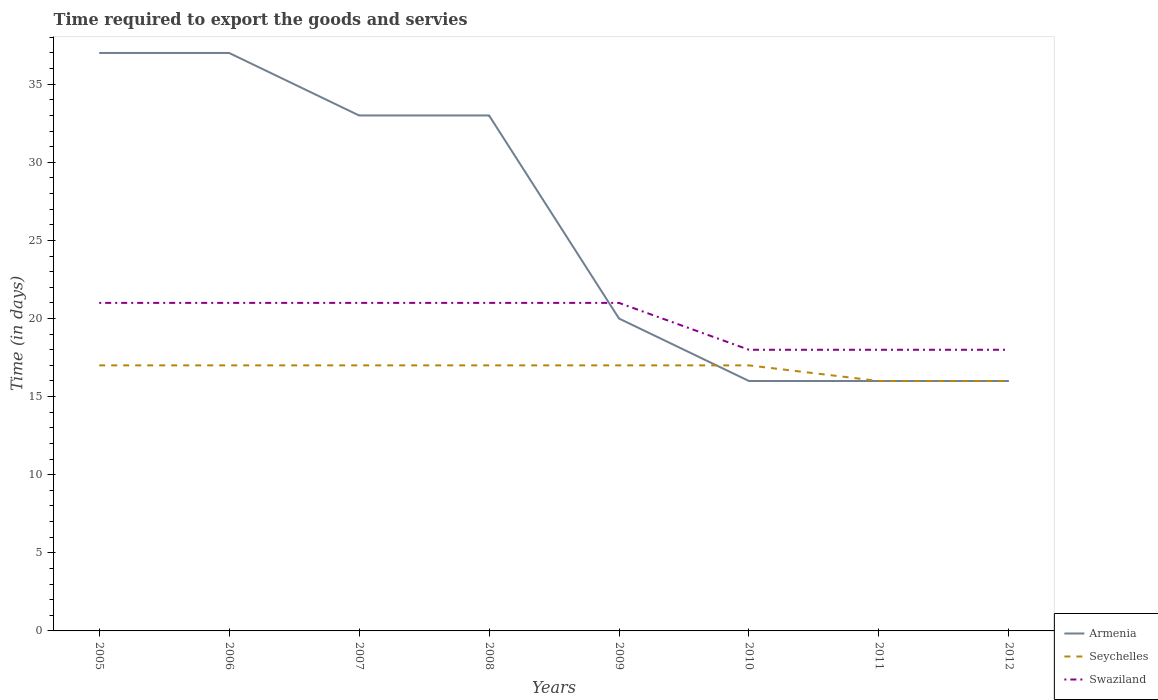Across all years, what is the maximum number of days required to export the goods and services in Swaziland?
Make the answer very short. 18. What is the total number of days required to export the goods and services in Armenia in the graph?
Your answer should be very brief. 13. What is the difference between the highest and the second highest number of days required to export the goods and services in Swaziland?
Your answer should be very brief. 3. What is the difference between the highest and the lowest number of days required to export the goods and services in Armenia?
Ensure brevity in your answer.  4. Is the number of days required to export the goods and services in Seychelles strictly greater than the number of days required to export the goods and services in Swaziland over the years?
Give a very brief answer. Yes. What is the difference between two consecutive major ticks on the Y-axis?
Offer a terse response. 5. Are the values on the major ticks of Y-axis written in scientific E-notation?
Keep it short and to the point. No. Does the graph contain any zero values?
Make the answer very short. No. How many legend labels are there?
Provide a short and direct response. 3. What is the title of the graph?
Ensure brevity in your answer.  Time required to export the goods and servies. Does "Austria" appear as one of the legend labels in the graph?
Ensure brevity in your answer.  No. What is the label or title of the Y-axis?
Your answer should be very brief. Time (in days). What is the Time (in days) in Armenia in 2005?
Ensure brevity in your answer.  37. What is the Time (in days) of Seychelles in 2006?
Keep it short and to the point. 17. What is the Time (in days) in Seychelles in 2007?
Give a very brief answer. 17. What is the Time (in days) in Swaziland in 2007?
Offer a terse response. 21. What is the Time (in days) in Armenia in 2008?
Your answer should be compact. 33. What is the Time (in days) in Seychelles in 2008?
Keep it short and to the point. 17. What is the Time (in days) in Swaziland in 2008?
Make the answer very short. 21. What is the Time (in days) of Seychelles in 2010?
Ensure brevity in your answer.  17. What is the Time (in days) in Swaziland in 2010?
Provide a succinct answer. 18. What is the Time (in days) of Armenia in 2011?
Provide a short and direct response. 16. What is the Time (in days) in Armenia in 2012?
Your response must be concise. 16. What is the Time (in days) of Seychelles in 2012?
Keep it short and to the point. 16. What is the Time (in days) of Swaziland in 2012?
Keep it short and to the point. 18. Across all years, what is the maximum Time (in days) in Swaziland?
Your answer should be compact. 21. Across all years, what is the minimum Time (in days) in Seychelles?
Keep it short and to the point. 16. Across all years, what is the minimum Time (in days) of Swaziland?
Ensure brevity in your answer.  18. What is the total Time (in days) in Armenia in the graph?
Your response must be concise. 208. What is the total Time (in days) in Seychelles in the graph?
Keep it short and to the point. 134. What is the total Time (in days) in Swaziland in the graph?
Make the answer very short. 159. What is the difference between the Time (in days) of Armenia in 2005 and that in 2006?
Provide a succinct answer. 0. What is the difference between the Time (in days) in Seychelles in 2005 and that in 2006?
Offer a very short reply. 0. What is the difference between the Time (in days) in Swaziland in 2005 and that in 2006?
Offer a very short reply. 0. What is the difference between the Time (in days) of Armenia in 2005 and that in 2007?
Your answer should be very brief. 4. What is the difference between the Time (in days) of Seychelles in 2005 and that in 2007?
Offer a terse response. 0. What is the difference between the Time (in days) of Armenia in 2005 and that in 2009?
Offer a very short reply. 17. What is the difference between the Time (in days) in Seychelles in 2005 and that in 2009?
Your answer should be very brief. 0. What is the difference between the Time (in days) of Swaziland in 2005 and that in 2009?
Keep it short and to the point. 0. What is the difference between the Time (in days) in Armenia in 2005 and that in 2010?
Make the answer very short. 21. What is the difference between the Time (in days) in Seychelles in 2005 and that in 2010?
Your answer should be compact. 0. What is the difference between the Time (in days) of Armenia in 2005 and that in 2011?
Your answer should be compact. 21. What is the difference between the Time (in days) in Seychelles in 2005 and that in 2012?
Your answer should be compact. 1. What is the difference between the Time (in days) of Seychelles in 2006 and that in 2007?
Keep it short and to the point. 0. What is the difference between the Time (in days) in Seychelles in 2006 and that in 2008?
Your answer should be compact. 0. What is the difference between the Time (in days) of Armenia in 2006 and that in 2010?
Your response must be concise. 21. What is the difference between the Time (in days) in Seychelles in 2006 and that in 2010?
Your answer should be very brief. 0. What is the difference between the Time (in days) in Armenia in 2006 and that in 2011?
Your answer should be very brief. 21. What is the difference between the Time (in days) in Swaziland in 2006 and that in 2011?
Your answer should be compact. 3. What is the difference between the Time (in days) of Armenia in 2006 and that in 2012?
Your answer should be very brief. 21. What is the difference between the Time (in days) of Seychelles in 2006 and that in 2012?
Your answer should be very brief. 1. What is the difference between the Time (in days) in Armenia in 2007 and that in 2008?
Give a very brief answer. 0. What is the difference between the Time (in days) in Seychelles in 2007 and that in 2008?
Your response must be concise. 0. What is the difference between the Time (in days) in Swaziland in 2007 and that in 2009?
Ensure brevity in your answer.  0. What is the difference between the Time (in days) in Swaziland in 2007 and that in 2010?
Give a very brief answer. 3. What is the difference between the Time (in days) in Seychelles in 2007 and that in 2011?
Keep it short and to the point. 1. What is the difference between the Time (in days) of Armenia in 2007 and that in 2012?
Ensure brevity in your answer.  17. What is the difference between the Time (in days) in Seychelles in 2007 and that in 2012?
Make the answer very short. 1. What is the difference between the Time (in days) in Swaziland in 2007 and that in 2012?
Offer a terse response. 3. What is the difference between the Time (in days) of Armenia in 2008 and that in 2009?
Your answer should be compact. 13. What is the difference between the Time (in days) of Seychelles in 2008 and that in 2009?
Give a very brief answer. 0. What is the difference between the Time (in days) of Armenia in 2008 and that in 2010?
Your answer should be compact. 17. What is the difference between the Time (in days) in Seychelles in 2008 and that in 2010?
Give a very brief answer. 0. What is the difference between the Time (in days) in Swaziland in 2008 and that in 2011?
Provide a succinct answer. 3. What is the difference between the Time (in days) in Armenia in 2008 and that in 2012?
Ensure brevity in your answer.  17. What is the difference between the Time (in days) of Seychelles in 2009 and that in 2010?
Make the answer very short. 0. What is the difference between the Time (in days) in Armenia in 2009 and that in 2011?
Make the answer very short. 4. What is the difference between the Time (in days) of Swaziland in 2009 and that in 2011?
Your answer should be compact. 3. What is the difference between the Time (in days) in Swaziland in 2010 and that in 2011?
Your answer should be very brief. 0. What is the difference between the Time (in days) of Seychelles in 2010 and that in 2012?
Give a very brief answer. 1. What is the difference between the Time (in days) of Swaziland in 2010 and that in 2012?
Make the answer very short. 0. What is the difference between the Time (in days) of Armenia in 2011 and that in 2012?
Keep it short and to the point. 0. What is the difference between the Time (in days) in Seychelles in 2011 and that in 2012?
Your response must be concise. 0. What is the difference between the Time (in days) in Swaziland in 2011 and that in 2012?
Keep it short and to the point. 0. What is the difference between the Time (in days) in Armenia in 2005 and the Time (in days) in Seychelles in 2006?
Offer a terse response. 20. What is the difference between the Time (in days) in Armenia in 2005 and the Time (in days) in Swaziland in 2007?
Your answer should be very brief. 16. What is the difference between the Time (in days) of Seychelles in 2005 and the Time (in days) of Swaziland in 2007?
Make the answer very short. -4. What is the difference between the Time (in days) in Armenia in 2005 and the Time (in days) in Seychelles in 2008?
Offer a terse response. 20. What is the difference between the Time (in days) in Armenia in 2005 and the Time (in days) in Swaziland in 2008?
Give a very brief answer. 16. What is the difference between the Time (in days) of Seychelles in 2005 and the Time (in days) of Swaziland in 2008?
Ensure brevity in your answer.  -4. What is the difference between the Time (in days) in Armenia in 2005 and the Time (in days) in Swaziland in 2009?
Provide a succinct answer. 16. What is the difference between the Time (in days) in Seychelles in 2005 and the Time (in days) in Swaziland in 2009?
Your response must be concise. -4. What is the difference between the Time (in days) of Armenia in 2005 and the Time (in days) of Seychelles in 2010?
Your answer should be very brief. 20. What is the difference between the Time (in days) of Armenia in 2005 and the Time (in days) of Swaziland in 2010?
Your answer should be compact. 19. What is the difference between the Time (in days) in Armenia in 2005 and the Time (in days) in Swaziland in 2011?
Your answer should be very brief. 19. What is the difference between the Time (in days) of Seychelles in 2005 and the Time (in days) of Swaziland in 2011?
Provide a short and direct response. -1. What is the difference between the Time (in days) in Armenia in 2005 and the Time (in days) in Seychelles in 2012?
Make the answer very short. 21. What is the difference between the Time (in days) in Armenia in 2005 and the Time (in days) in Swaziland in 2012?
Provide a short and direct response. 19. What is the difference between the Time (in days) in Armenia in 2006 and the Time (in days) in Swaziland in 2007?
Provide a short and direct response. 16. What is the difference between the Time (in days) in Seychelles in 2006 and the Time (in days) in Swaziland in 2007?
Offer a very short reply. -4. What is the difference between the Time (in days) in Armenia in 2006 and the Time (in days) in Seychelles in 2008?
Offer a terse response. 20. What is the difference between the Time (in days) in Armenia in 2006 and the Time (in days) in Swaziland in 2008?
Provide a short and direct response. 16. What is the difference between the Time (in days) in Armenia in 2006 and the Time (in days) in Seychelles in 2009?
Make the answer very short. 20. What is the difference between the Time (in days) in Seychelles in 2006 and the Time (in days) in Swaziland in 2009?
Make the answer very short. -4. What is the difference between the Time (in days) in Seychelles in 2006 and the Time (in days) in Swaziland in 2010?
Your answer should be very brief. -1. What is the difference between the Time (in days) of Armenia in 2006 and the Time (in days) of Swaziland in 2012?
Provide a short and direct response. 19. What is the difference between the Time (in days) in Seychelles in 2006 and the Time (in days) in Swaziland in 2012?
Offer a very short reply. -1. What is the difference between the Time (in days) of Seychelles in 2007 and the Time (in days) of Swaziland in 2008?
Ensure brevity in your answer.  -4. What is the difference between the Time (in days) of Seychelles in 2007 and the Time (in days) of Swaziland in 2009?
Give a very brief answer. -4. What is the difference between the Time (in days) in Armenia in 2007 and the Time (in days) in Swaziland in 2010?
Keep it short and to the point. 15. What is the difference between the Time (in days) of Seychelles in 2007 and the Time (in days) of Swaziland in 2010?
Your response must be concise. -1. What is the difference between the Time (in days) in Armenia in 2007 and the Time (in days) in Swaziland in 2011?
Provide a short and direct response. 15. What is the difference between the Time (in days) in Armenia in 2007 and the Time (in days) in Seychelles in 2012?
Give a very brief answer. 17. What is the difference between the Time (in days) in Seychelles in 2008 and the Time (in days) in Swaziland in 2009?
Provide a short and direct response. -4. What is the difference between the Time (in days) in Armenia in 2008 and the Time (in days) in Seychelles in 2010?
Offer a very short reply. 16. What is the difference between the Time (in days) of Seychelles in 2008 and the Time (in days) of Swaziland in 2010?
Give a very brief answer. -1. What is the difference between the Time (in days) of Armenia in 2008 and the Time (in days) of Swaziland in 2011?
Provide a short and direct response. 15. What is the difference between the Time (in days) of Armenia in 2009 and the Time (in days) of Swaziland in 2010?
Your response must be concise. 2. What is the difference between the Time (in days) in Seychelles in 2009 and the Time (in days) in Swaziland in 2010?
Make the answer very short. -1. What is the difference between the Time (in days) of Armenia in 2009 and the Time (in days) of Swaziland in 2011?
Your answer should be very brief. 2. What is the difference between the Time (in days) of Armenia in 2009 and the Time (in days) of Seychelles in 2012?
Your response must be concise. 4. What is the difference between the Time (in days) in Armenia in 2009 and the Time (in days) in Swaziland in 2012?
Your answer should be very brief. 2. What is the difference between the Time (in days) in Seychelles in 2009 and the Time (in days) in Swaziland in 2012?
Offer a very short reply. -1. What is the difference between the Time (in days) in Armenia in 2010 and the Time (in days) in Seychelles in 2011?
Ensure brevity in your answer.  0. What is the difference between the Time (in days) in Armenia in 2010 and the Time (in days) in Swaziland in 2011?
Provide a succinct answer. -2. What is the difference between the Time (in days) in Seychelles in 2010 and the Time (in days) in Swaziland in 2011?
Provide a short and direct response. -1. What is the difference between the Time (in days) of Armenia in 2010 and the Time (in days) of Seychelles in 2012?
Give a very brief answer. 0. What is the difference between the Time (in days) of Armenia in 2010 and the Time (in days) of Swaziland in 2012?
Provide a succinct answer. -2. What is the difference between the Time (in days) in Armenia in 2011 and the Time (in days) in Swaziland in 2012?
Provide a succinct answer. -2. What is the difference between the Time (in days) in Seychelles in 2011 and the Time (in days) in Swaziland in 2012?
Provide a short and direct response. -2. What is the average Time (in days) of Seychelles per year?
Your answer should be compact. 16.75. What is the average Time (in days) of Swaziland per year?
Ensure brevity in your answer.  19.88. In the year 2005, what is the difference between the Time (in days) of Armenia and Time (in days) of Seychelles?
Provide a short and direct response. 20. In the year 2005, what is the difference between the Time (in days) in Armenia and Time (in days) in Swaziland?
Your answer should be very brief. 16. In the year 2006, what is the difference between the Time (in days) in Armenia and Time (in days) in Swaziland?
Offer a terse response. 16. In the year 2007, what is the difference between the Time (in days) in Armenia and Time (in days) in Swaziland?
Provide a succinct answer. 12. In the year 2008, what is the difference between the Time (in days) in Armenia and Time (in days) in Seychelles?
Your answer should be very brief. 16. In the year 2008, what is the difference between the Time (in days) in Seychelles and Time (in days) in Swaziland?
Offer a terse response. -4. In the year 2009, what is the difference between the Time (in days) of Armenia and Time (in days) of Seychelles?
Your answer should be compact. 3. In the year 2010, what is the difference between the Time (in days) in Seychelles and Time (in days) in Swaziland?
Ensure brevity in your answer.  -1. In the year 2012, what is the difference between the Time (in days) of Seychelles and Time (in days) of Swaziland?
Offer a terse response. -2. What is the ratio of the Time (in days) in Armenia in 2005 to that in 2006?
Provide a succinct answer. 1. What is the ratio of the Time (in days) in Armenia in 2005 to that in 2007?
Your answer should be compact. 1.12. What is the ratio of the Time (in days) in Armenia in 2005 to that in 2008?
Give a very brief answer. 1.12. What is the ratio of the Time (in days) of Seychelles in 2005 to that in 2008?
Offer a terse response. 1. What is the ratio of the Time (in days) of Swaziland in 2005 to that in 2008?
Provide a succinct answer. 1. What is the ratio of the Time (in days) in Armenia in 2005 to that in 2009?
Your answer should be compact. 1.85. What is the ratio of the Time (in days) in Seychelles in 2005 to that in 2009?
Offer a very short reply. 1. What is the ratio of the Time (in days) of Swaziland in 2005 to that in 2009?
Provide a succinct answer. 1. What is the ratio of the Time (in days) of Armenia in 2005 to that in 2010?
Your response must be concise. 2.31. What is the ratio of the Time (in days) in Armenia in 2005 to that in 2011?
Your answer should be very brief. 2.31. What is the ratio of the Time (in days) of Seychelles in 2005 to that in 2011?
Keep it short and to the point. 1.06. What is the ratio of the Time (in days) of Armenia in 2005 to that in 2012?
Keep it short and to the point. 2.31. What is the ratio of the Time (in days) of Seychelles in 2005 to that in 2012?
Make the answer very short. 1.06. What is the ratio of the Time (in days) in Swaziland in 2005 to that in 2012?
Ensure brevity in your answer.  1.17. What is the ratio of the Time (in days) in Armenia in 2006 to that in 2007?
Offer a very short reply. 1.12. What is the ratio of the Time (in days) in Seychelles in 2006 to that in 2007?
Provide a succinct answer. 1. What is the ratio of the Time (in days) in Swaziland in 2006 to that in 2007?
Keep it short and to the point. 1. What is the ratio of the Time (in days) of Armenia in 2006 to that in 2008?
Provide a short and direct response. 1.12. What is the ratio of the Time (in days) in Seychelles in 2006 to that in 2008?
Give a very brief answer. 1. What is the ratio of the Time (in days) in Armenia in 2006 to that in 2009?
Make the answer very short. 1.85. What is the ratio of the Time (in days) in Armenia in 2006 to that in 2010?
Give a very brief answer. 2.31. What is the ratio of the Time (in days) of Seychelles in 2006 to that in 2010?
Your response must be concise. 1. What is the ratio of the Time (in days) of Swaziland in 2006 to that in 2010?
Make the answer very short. 1.17. What is the ratio of the Time (in days) of Armenia in 2006 to that in 2011?
Ensure brevity in your answer.  2.31. What is the ratio of the Time (in days) of Armenia in 2006 to that in 2012?
Keep it short and to the point. 2.31. What is the ratio of the Time (in days) in Seychelles in 2006 to that in 2012?
Your answer should be compact. 1.06. What is the ratio of the Time (in days) of Swaziland in 2006 to that in 2012?
Keep it short and to the point. 1.17. What is the ratio of the Time (in days) of Armenia in 2007 to that in 2008?
Give a very brief answer. 1. What is the ratio of the Time (in days) of Seychelles in 2007 to that in 2008?
Your answer should be very brief. 1. What is the ratio of the Time (in days) in Armenia in 2007 to that in 2009?
Give a very brief answer. 1.65. What is the ratio of the Time (in days) of Armenia in 2007 to that in 2010?
Give a very brief answer. 2.06. What is the ratio of the Time (in days) in Seychelles in 2007 to that in 2010?
Your answer should be compact. 1. What is the ratio of the Time (in days) in Armenia in 2007 to that in 2011?
Your response must be concise. 2.06. What is the ratio of the Time (in days) in Armenia in 2007 to that in 2012?
Provide a succinct answer. 2.06. What is the ratio of the Time (in days) in Seychelles in 2007 to that in 2012?
Offer a terse response. 1.06. What is the ratio of the Time (in days) in Armenia in 2008 to that in 2009?
Offer a terse response. 1.65. What is the ratio of the Time (in days) of Seychelles in 2008 to that in 2009?
Ensure brevity in your answer.  1. What is the ratio of the Time (in days) of Armenia in 2008 to that in 2010?
Keep it short and to the point. 2.06. What is the ratio of the Time (in days) of Swaziland in 2008 to that in 2010?
Keep it short and to the point. 1.17. What is the ratio of the Time (in days) of Armenia in 2008 to that in 2011?
Your answer should be compact. 2.06. What is the ratio of the Time (in days) of Seychelles in 2008 to that in 2011?
Your answer should be very brief. 1.06. What is the ratio of the Time (in days) of Armenia in 2008 to that in 2012?
Offer a very short reply. 2.06. What is the ratio of the Time (in days) of Swaziland in 2008 to that in 2012?
Your answer should be compact. 1.17. What is the ratio of the Time (in days) in Seychelles in 2009 to that in 2010?
Provide a short and direct response. 1. What is the ratio of the Time (in days) in Swaziland in 2009 to that in 2012?
Provide a short and direct response. 1.17. What is the ratio of the Time (in days) of Armenia in 2010 to that in 2011?
Ensure brevity in your answer.  1. What is the ratio of the Time (in days) of Swaziland in 2010 to that in 2011?
Make the answer very short. 1. What is the ratio of the Time (in days) in Swaziland in 2010 to that in 2012?
Provide a short and direct response. 1. What is the ratio of the Time (in days) of Swaziland in 2011 to that in 2012?
Offer a terse response. 1. What is the difference between the highest and the second highest Time (in days) in Armenia?
Offer a very short reply. 0. What is the difference between the highest and the second highest Time (in days) of Seychelles?
Offer a very short reply. 0. What is the difference between the highest and the second highest Time (in days) in Swaziland?
Offer a terse response. 0. What is the difference between the highest and the lowest Time (in days) of Armenia?
Give a very brief answer. 21. What is the difference between the highest and the lowest Time (in days) of Swaziland?
Make the answer very short. 3. 